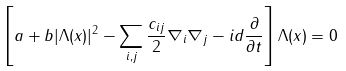Convert formula to latex. <formula><loc_0><loc_0><loc_500><loc_500>\left [ a + b | \Lambda ( x ) | ^ { 2 } - \sum _ { i , j } \frac { c _ { i j } } { 2 } \nabla _ { i } \nabla _ { j } - i d \frac { \partial } { \partial t } \right ] \Lambda ( x ) = 0</formula> 